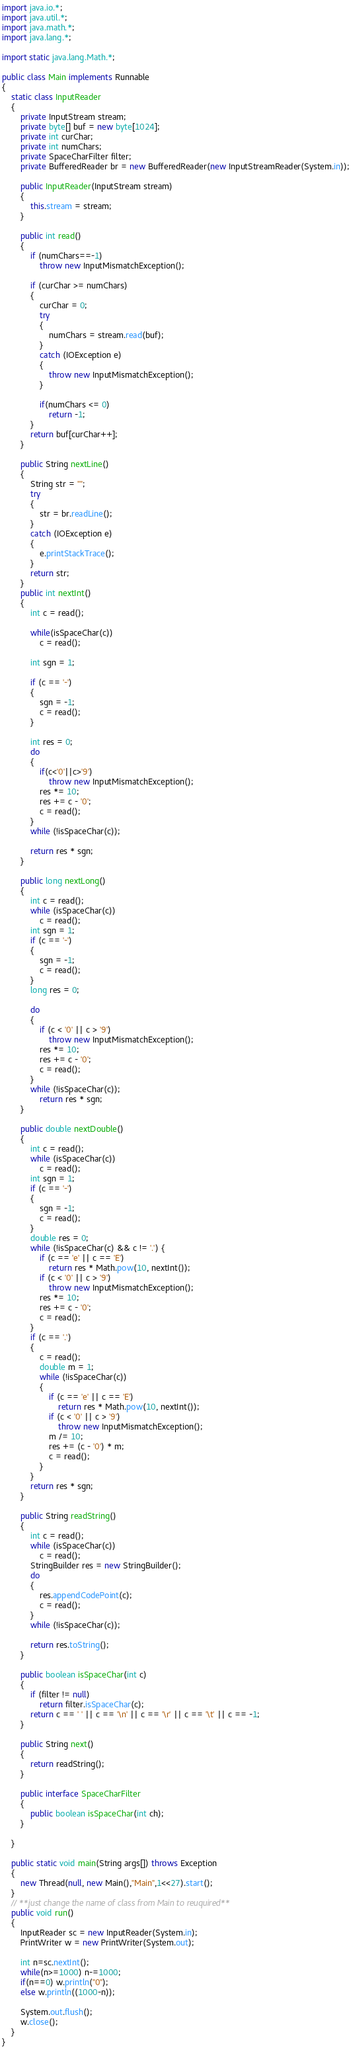<code> <loc_0><loc_0><loc_500><loc_500><_Java_>import java.io.*;
import java.util.*;
import java.math.*;
import java.lang.*;
 
import static java.lang.Math.*;

public class Main implements Runnable 
{
    static class InputReader 
    {
        private InputStream stream;
        private byte[] buf = new byte[1024];
        private int curChar;
        private int numChars;
        private SpaceCharFilter filter;
        private BufferedReader br = new BufferedReader(new InputStreamReader(System.in));

        public InputReader(InputStream stream) 
        {
            this.stream = stream;
        }
        
        public int read()
        {
            if (numChars==-1) 
                throw new InputMismatchException();
            
            if (curChar >= numChars) 
            {
                curChar = 0;
                try
                {
                    numChars = stream.read(buf);
                }
                catch (IOException e)
                {
                    throw new InputMismatchException();
                }
                
                if(numChars <= 0)               
                    return -1;
            }
            return buf[curChar++];
        }
     
        public String nextLine()
        {
            String str = "";
            try
            {
                str = br.readLine();
            }
            catch (IOException e)
            {
                e.printStackTrace();
            }
            return str;
        }
        public int nextInt() 
        {
            int c = read();
            
            while(isSpaceChar(c)) 
                c = read();
            
            int sgn = 1;
        
            if (c == '-') 
            {
                sgn = -1;
                c = read();
            }
            
            int res = 0;
            do
            {
                if(c<'0'||c>'9') 
                    throw new InputMismatchException();
                res *= 10;
                res += c - '0';
                c = read();
            }
            while (!isSpaceChar(c)); 
        
            return res * sgn;
        }
		
        public long nextLong() 
        {
            int c = read();
            while (isSpaceChar(c))
                c = read();
            int sgn = 1;
            if (c == '-')
            {
                sgn = -1;
                c = read();
            }
            long res = 0;
            
            do 
            {
                if (c < '0' || c > '9')
                    throw new InputMismatchException();
                res *= 10;
                res += c - '0';
                c = read();
            }
            while (!isSpaceChar(c));
                return res * sgn;
        }
		
        public double nextDouble() 
        {
            int c = read();
            while (isSpaceChar(c))
                c = read();
            int sgn = 1;
            if (c == '-')
            {
                sgn = -1;
                c = read();
            }
            double res = 0;
            while (!isSpaceChar(c) && c != '.') {
                if (c == 'e' || c == 'E')
                    return res * Math.pow(10, nextInt());
                if (c < '0' || c > '9')
                    throw new InputMismatchException();
                res *= 10;
                res += c - '0';
                c = read();
            }
            if (c == '.') 
            {
                c = read();
                double m = 1;
                while (!isSpaceChar(c))
                {
                    if (c == 'e' || c == 'E')
                        return res * Math.pow(10, nextInt());
                    if (c < '0' || c > '9')
                        throw new InputMismatchException();
                    m /= 10;
                    res += (c - '0') * m;
                    c = read();
                }
            }
            return res * sgn;
        }
    
        public String readString() 
        {
            int c = read();
            while (isSpaceChar(c))
                c = read();
            StringBuilder res = new StringBuilder();
            do 
            {
                res.appendCodePoint(c);
                c = read();
            } 
            while (!isSpaceChar(c));
            
            return res.toString();
        }
     
        public boolean isSpaceChar(int c) 
        {
            if (filter != null)
                return filter.isSpaceChar(c);
            return c == ' ' || c == '\n' || c == '\r' || c == '\t' || c == -1;
        }
     
        public String next()
        {
            return readString();
        }
        
        public interface SpaceCharFilter
        {
            public boolean isSpaceChar(int ch);
        }
		
    }
	
    public static void main(String args[]) throws Exception 
    {
        new Thread(null, new Main(),"Main",1<<27).start();
    }
	// **just change the name of class from Main to reuquired**
    public void run()
    {
        InputReader sc = new InputReader(System.in);
        PrintWriter w = new PrintWriter(System.out);
		
		int n=sc.nextInt();
		while(n>=1000) n-=1000;
		if(n==0) w.println("0");
		else w.println((1000-n));
		
        System.out.flush();
        w.close();
    }
}</code> 